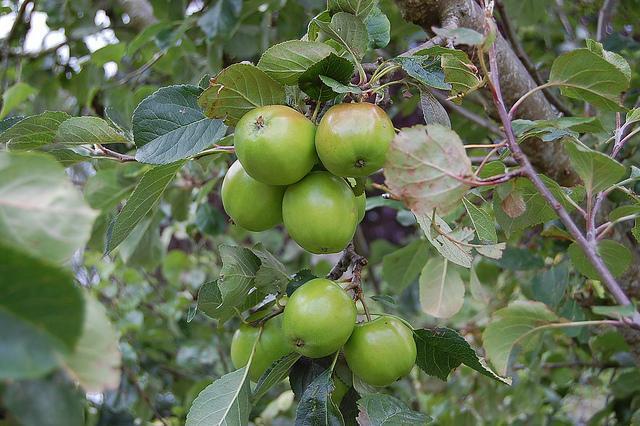How many apples are in the picture?
Give a very brief answer. 7. 